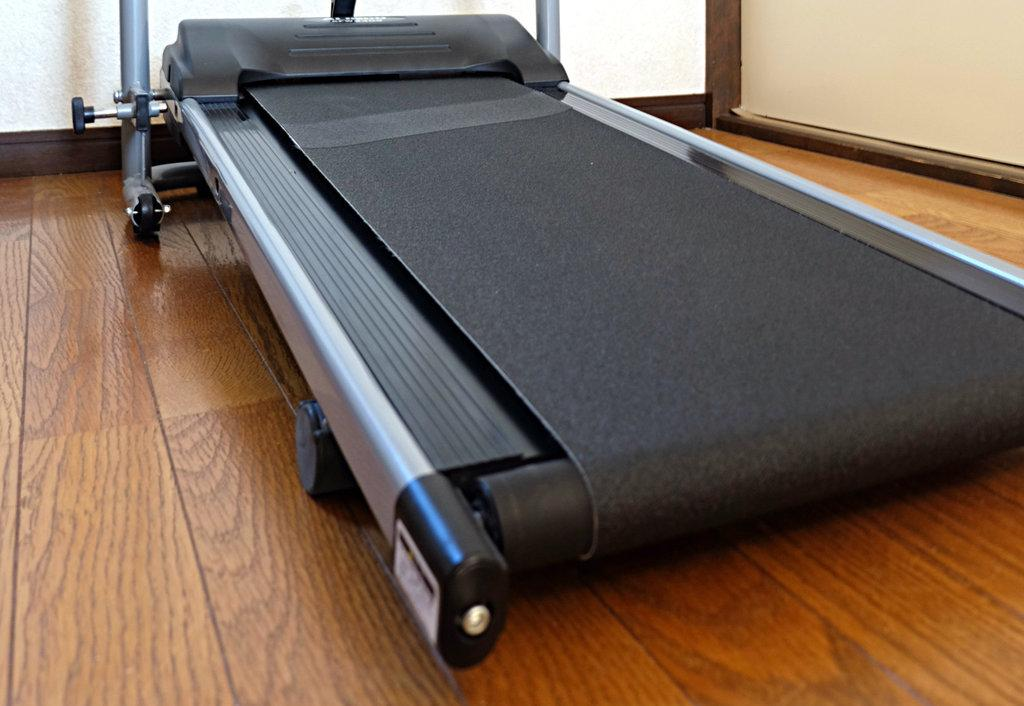What type of exercise equipment is present in the image? There is a treadmill in the image. What material is used for the surface in the image? There is a wooden surface in the image. How many babies are present in the image? There are no babies present in the image. What is the end result of using the treadmill in the image? The image does not show the end result of using the treadmill, as it only depicts the equipment itself. 